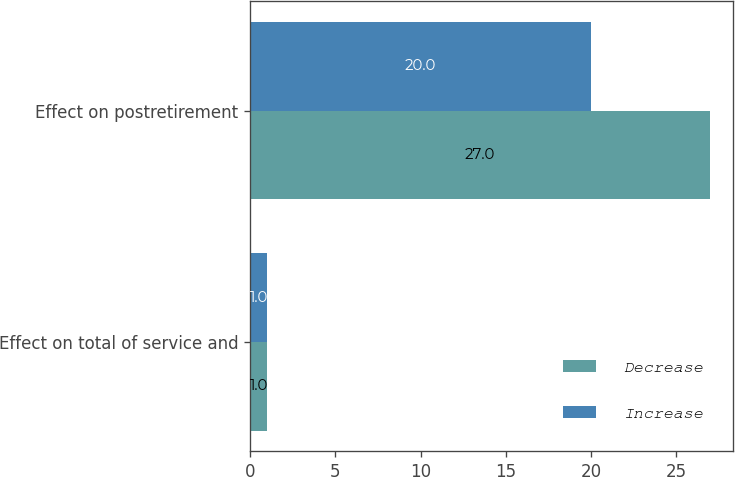Convert chart to OTSL. <chart><loc_0><loc_0><loc_500><loc_500><stacked_bar_chart><ecel><fcel>Effect on total of service and<fcel>Effect on postretirement<nl><fcel>Decrease<fcel>1<fcel>27<nl><fcel>Increase<fcel>1<fcel>20<nl></chart> 